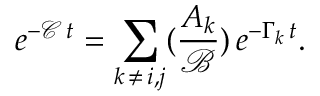<formula> <loc_0><loc_0><loc_500><loc_500>e ^ { - \mathcal { C } \, t } = \sum _ { k \, \neq \, i , j } ( \frac { A _ { k } } { \mathcal { B } } ) \, e ^ { - \Gamma _ { k } \, t } .</formula> 